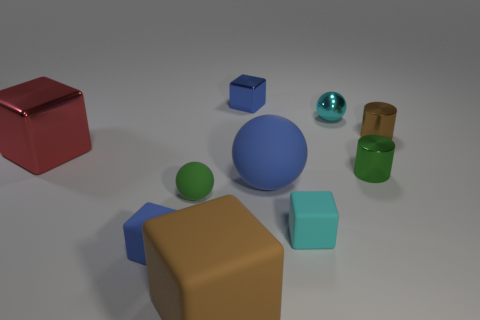Subtract all cyan cubes. How many cubes are left? 4 Subtract all blue cubes. How many cubes are left? 3 Subtract 4 blocks. How many blocks are left? 1 Subtract 0 blue cylinders. How many objects are left? 10 Subtract all cylinders. How many objects are left? 8 Subtract all gray cubes. Subtract all gray cylinders. How many cubes are left? 5 Subtract all yellow spheres. How many green cylinders are left? 1 Subtract all brown matte blocks. Subtract all big red things. How many objects are left? 8 Add 5 rubber cubes. How many rubber cubes are left? 8 Add 3 small purple matte cylinders. How many small purple matte cylinders exist? 3 